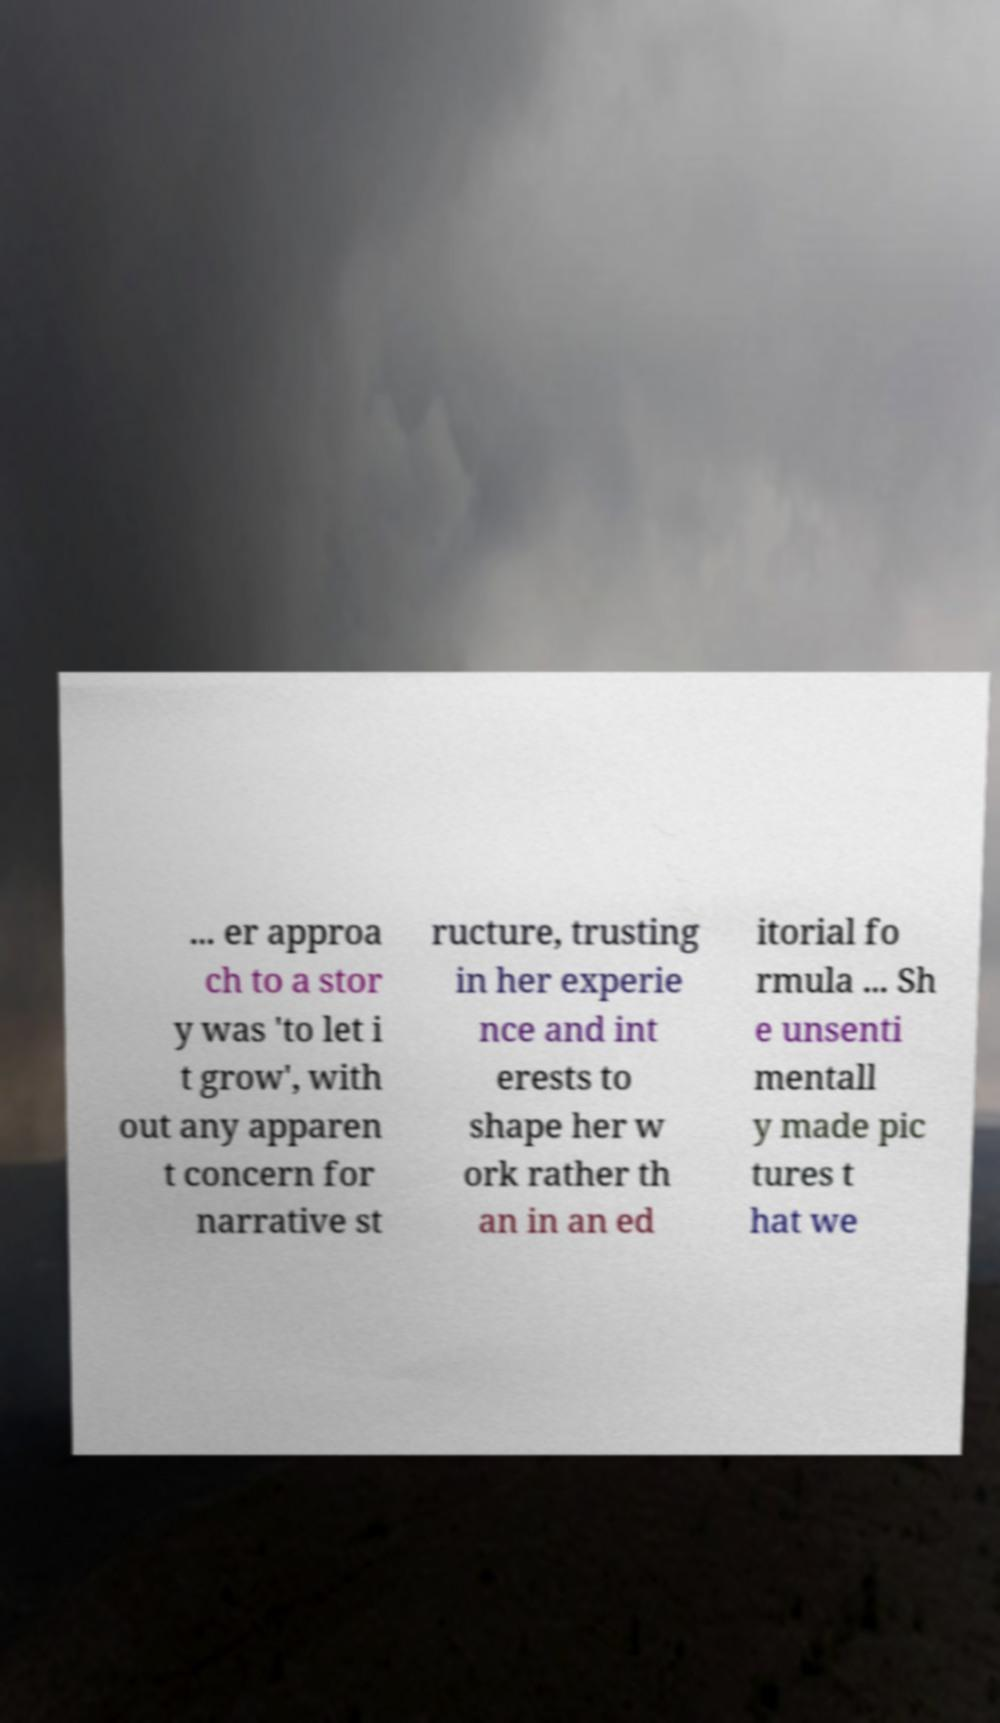I need the written content from this picture converted into text. Can you do that? ... er approa ch to a stor y was 'to let i t grow', with out any apparen t concern for narrative st ructure, trusting in her experie nce and int erests to shape her w ork rather th an in an ed itorial fo rmula ... Sh e unsenti mentall y made pic tures t hat we 